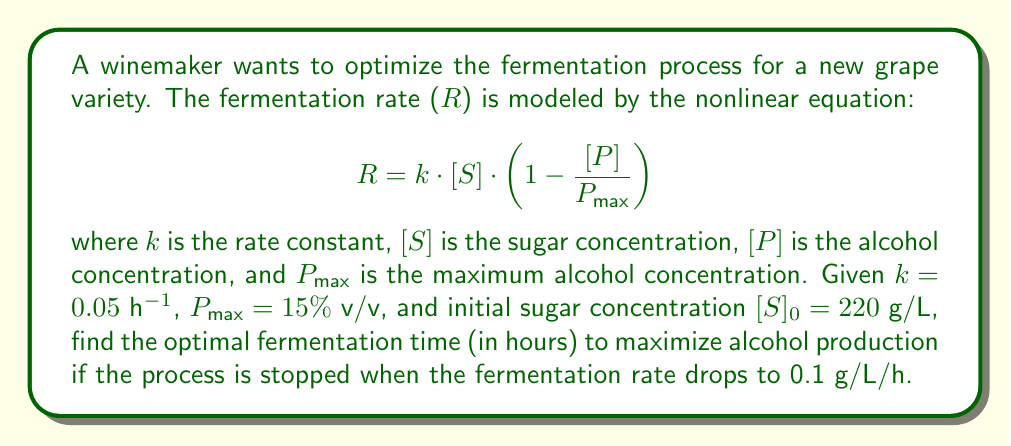Provide a solution to this math problem. To solve this problem, we need to follow these steps:

1) First, we need to understand that as fermentation progresses, $[S]$ decreases and $[P]$ increases. We can relate these changes:

   $$\Delta[P] = -0.511 \cdot \Delta[S]$$

   This factor (0.511) comes from the stoichiometry of the fermentation reaction.

2) At any given time, $[S] + [P]/0.511 = [S]_0$. Let's substitute this into our rate equation:

   $$R = 0.05 \cdot [S] \cdot \left(1 - \frac{[S]_0 - [S]}{0.511 \cdot 15}\right)$$

3) We want to find when $R = 0.1$ g/L/h. Let's set up this equation:

   $$0.1 = 0.05 \cdot [S] \cdot \left(1 - \frac{220 - [S]}{0.511 \cdot 15}\right)$$

4) This is a quadratic equation in $[S]$. Solving it (you can use the quadratic formula), we get:

   $$[S] \approx 13.45$$ g/L

5) Now we need to find how long it takes to reach this sugar concentration. We can integrate the rate equation:

   $$t = \int_{[S]_0}^{[S]} \frac{d[S]}{R}$$

6) This integral doesn't have a simple analytical solution, so we need to use numerical methods. Using a computer algebra system or numerical integration tool, we find:

   $$t \approx 162.3$$ hours

This is the optimal fermentation time to maximize alcohol production under the given constraints.
Answer: 162.3 hours 